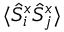<formula> <loc_0><loc_0><loc_500><loc_500>\langle \hat { S } _ { i } ^ { x } \hat { S } _ { j } ^ { x } \rangle</formula> 